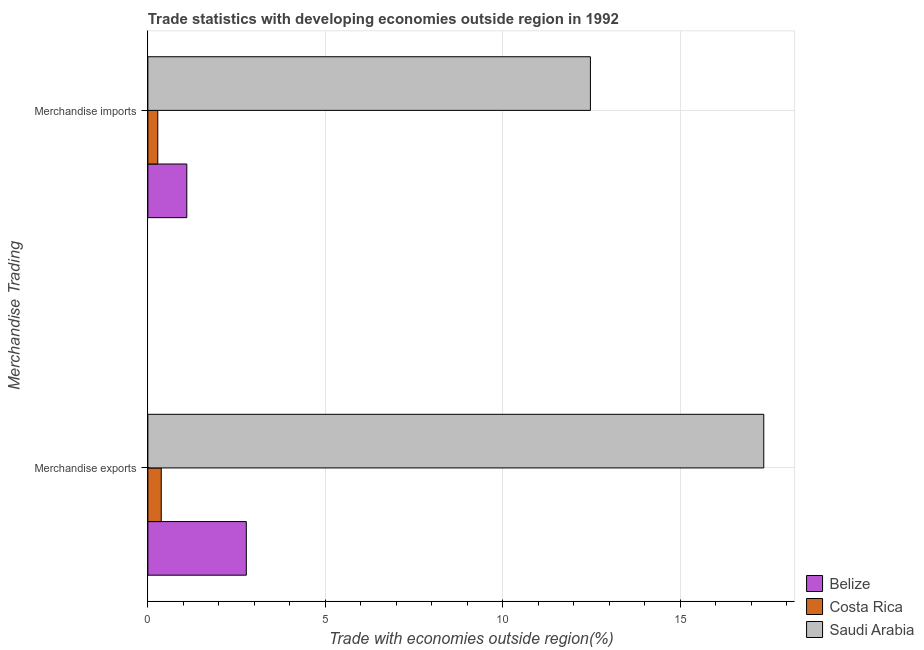How many different coloured bars are there?
Provide a short and direct response. 3. How many groups of bars are there?
Ensure brevity in your answer.  2. Are the number of bars on each tick of the Y-axis equal?
Your response must be concise. Yes. How many bars are there on the 1st tick from the top?
Provide a succinct answer. 3. How many bars are there on the 2nd tick from the bottom?
Provide a short and direct response. 3. What is the merchandise imports in Saudi Arabia?
Your response must be concise. 12.47. Across all countries, what is the maximum merchandise imports?
Your answer should be very brief. 12.47. Across all countries, what is the minimum merchandise exports?
Provide a succinct answer. 0.38. In which country was the merchandise exports maximum?
Make the answer very short. Saudi Arabia. In which country was the merchandise exports minimum?
Your response must be concise. Costa Rica. What is the total merchandise exports in the graph?
Your response must be concise. 20.5. What is the difference between the merchandise imports in Belize and that in Saudi Arabia?
Your response must be concise. -11.37. What is the difference between the merchandise imports in Costa Rica and the merchandise exports in Belize?
Make the answer very short. -2.49. What is the average merchandise imports per country?
Your response must be concise. 4.62. What is the difference between the merchandise exports and merchandise imports in Costa Rica?
Keep it short and to the point. 0.1. What is the ratio of the merchandise exports in Belize to that in Saudi Arabia?
Offer a terse response. 0.16. Is the merchandise exports in Belize less than that in Saudi Arabia?
Keep it short and to the point. Yes. In how many countries, is the merchandise exports greater than the average merchandise exports taken over all countries?
Give a very brief answer. 1. What does the 2nd bar from the top in Merchandise imports represents?
Keep it short and to the point. Costa Rica. How many bars are there?
Your answer should be compact. 6. Are all the bars in the graph horizontal?
Offer a very short reply. Yes. Are the values on the major ticks of X-axis written in scientific E-notation?
Make the answer very short. No. Does the graph contain grids?
Provide a short and direct response. Yes. Where does the legend appear in the graph?
Your answer should be compact. Bottom right. How many legend labels are there?
Provide a succinct answer. 3. What is the title of the graph?
Give a very brief answer. Trade statistics with developing economies outside region in 1992. Does "East Asia (all income levels)" appear as one of the legend labels in the graph?
Your answer should be very brief. No. What is the label or title of the X-axis?
Offer a terse response. Trade with economies outside region(%). What is the label or title of the Y-axis?
Your response must be concise. Merchandise Trading. What is the Trade with economies outside region(%) in Belize in Merchandise exports?
Your response must be concise. 2.77. What is the Trade with economies outside region(%) in Costa Rica in Merchandise exports?
Provide a succinct answer. 0.38. What is the Trade with economies outside region(%) of Saudi Arabia in Merchandise exports?
Your answer should be very brief. 17.35. What is the Trade with economies outside region(%) of Belize in Merchandise imports?
Your response must be concise. 1.1. What is the Trade with economies outside region(%) of Costa Rica in Merchandise imports?
Give a very brief answer. 0.28. What is the Trade with economies outside region(%) of Saudi Arabia in Merchandise imports?
Keep it short and to the point. 12.47. Across all Merchandise Trading, what is the maximum Trade with economies outside region(%) of Belize?
Provide a succinct answer. 2.77. Across all Merchandise Trading, what is the maximum Trade with economies outside region(%) of Costa Rica?
Ensure brevity in your answer.  0.38. Across all Merchandise Trading, what is the maximum Trade with economies outside region(%) in Saudi Arabia?
Your response must be concise. 17.35. Across all Merchandise Trading, what is the minimum Trade with economies outside region(%) of Belize?
Offer a very short reply. 1.1. Across all Merchandise Trading, what is the minimum Trade with economies outside region(%) of Costa Rica?
Your answer should be very brief. 0.28. Across all Merchandise Trading, what is the minimum Trade with economies outside region(%) of Saudi Arabia?
Offer a very short reply. 12.47. What is the total Trade with economies outside region(%) in Belize in the graph?
Your answer should be very brief. 3.87. What is the total Trade with economies outside region(%) of Costa Rica in the graph?
Keep it short and to the point. 0.66. What is the total Trade with economies outside region(%) of Saudi Arabia in the graph?
Make the answer very short. 29.82. What is the difference between the Trade with economies outside region(%) of Belize in Merchandise exports and that in Merchandise imports?
Offer a terse response. 1.68. What is the difference between the Trade with economies outside region(%) in Costa Rica in Merchandise exports and that in Merchandise imports?
Provide a succinct answer. 0.1. What is the difference between the Trade with economies outside region(%) of Saudi Arabia in Merchandise exports and that in Merchandise imports?
Provide a succinct answer. 4.88. What is the difference between the Trade with economies outside region(%) of Belize in Merchandise exports and the Trade with economies outside region(%) of Costa Rica in Merchandise imports?
Offer a terse response. 2.49. What is the difference between the Trade with economies outside region(%) in Belize in Merchandise exports and the Trade with economies outside region(%) in Saudi Arabia in Merchandise imports?
Keep it short and to the point. -9.69. What is the difference between the Trade with economies outside region(%) in Costa Rica in Merchandise exports and the Trade with economies outside region(%) in Saudi Arabia in Merchandise imports?
Offer a very short reply. -12.09. What is the average Trade with economies outside region(%) in Belize per Merchandise Trading?
Your answer should be compact. 1.94. What is the average Trade with economies outside region(%) in Costa Rica per Merchandise Trading?
Offer a very short reply. 0.33. What is the average Trade with economies outside region(%) of Saudi Arabia per Merchandise Trading?
Your response must be concise. 14.91. What is the difference between the Trade with economies outside region(%) in Belize and Trade with economies outside region(%) in Costa Rica in Merchandise exports?
Make the answer very short. 2.4. What is the difference between the Trade with economies outside region(%) of Belize and Trade with economies outside region(%) of Saudi Arabia in Merchandise exports?
Make the answer very short. -14.58. What is the difference between the Trade with economies outside region(%) of Costa Rica and Trade with economies outside region(%) of Saudi Arabia in Merchandise exports?
Give a very brief answer. -16.98. What is the difference between the Trade with economies outside region(%) in Belize and Trade with economies outside region(%) in Costa Rica in Merchandise imports?
Offer a very short reply. 0.82. What is the difference between the Trade with economies outside region(%) in Belize and Trade with economies outside region(%) in Saudi Arabia in Merchandise imports?
Give a very brief answer. -11.37. What is the difference between the Trade with economies outside region(%) in Costa Rica and Trade with economies outside region(%) in Saudi Arabia in Merchandise imports?
Provide a succinct answer. -12.19. What is the ratio of the Trade with economies outside region(%) in Belize in Merchandise exports to that in Merchandise imports?
Ensure brevity in your answer.  2.53. What is the ratio of the Trade with economies outside region(%) of Costa Rica in Merchandise exports to that in Merchandise imports?
Provide a short and direct response. 1.35. What is the ratio of the Trade with economies outside region(%) in Saudi Arabia in Merchandise exports to that in Merchandise imports?
Your answer should be compact. 1.39. What is the difference between the highest and the second highest Trade with economies outside region(%) of Belize?
Provide a succinct answer. 1.68. What is the difference between the highest and the second highest Trade with economies outside region(%) of Costa Rica?
Keep it short and to the point. 0.1. What is the difference between the highest and the second highest Trade with economies outside region(%) of Saudi Arabia?
Keep it short and to the point. 4.88. What is the difference between the highest and the lowest Trade with economies outside region(%) of Belize?
Your response must be concise. 1.68. What is the difference between the highest and the lowest Trade with economies outside region(%) in Costa Rica?
Your answer should be very brief. 0.1. What is the difference between the highest and the lowest Trade with economies outside region(%) of Saudi Arabia?
Your answer should be very brief. 4.88. 